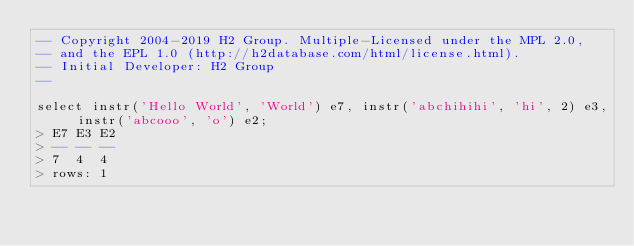Convert code to text. <code><loc_0><loc_0><loc_500><loc_500><_SQL_>-- Copyright 2004-2019 H2 Group. Multiple-Licensed under the MPL 2.0,
-- and the EPL 1.0 (http://h2database.com/html/license.html).
-- Initial Developer: H2 Group
--

select instr('Hello World', 'World') e7, instr('abchihihi', 'hi', 2) e3, instr('abcooo', 'o') e2;
> E7 E3 E2
> -- -- --
> 7  4  4
> rows: 1
</code> 